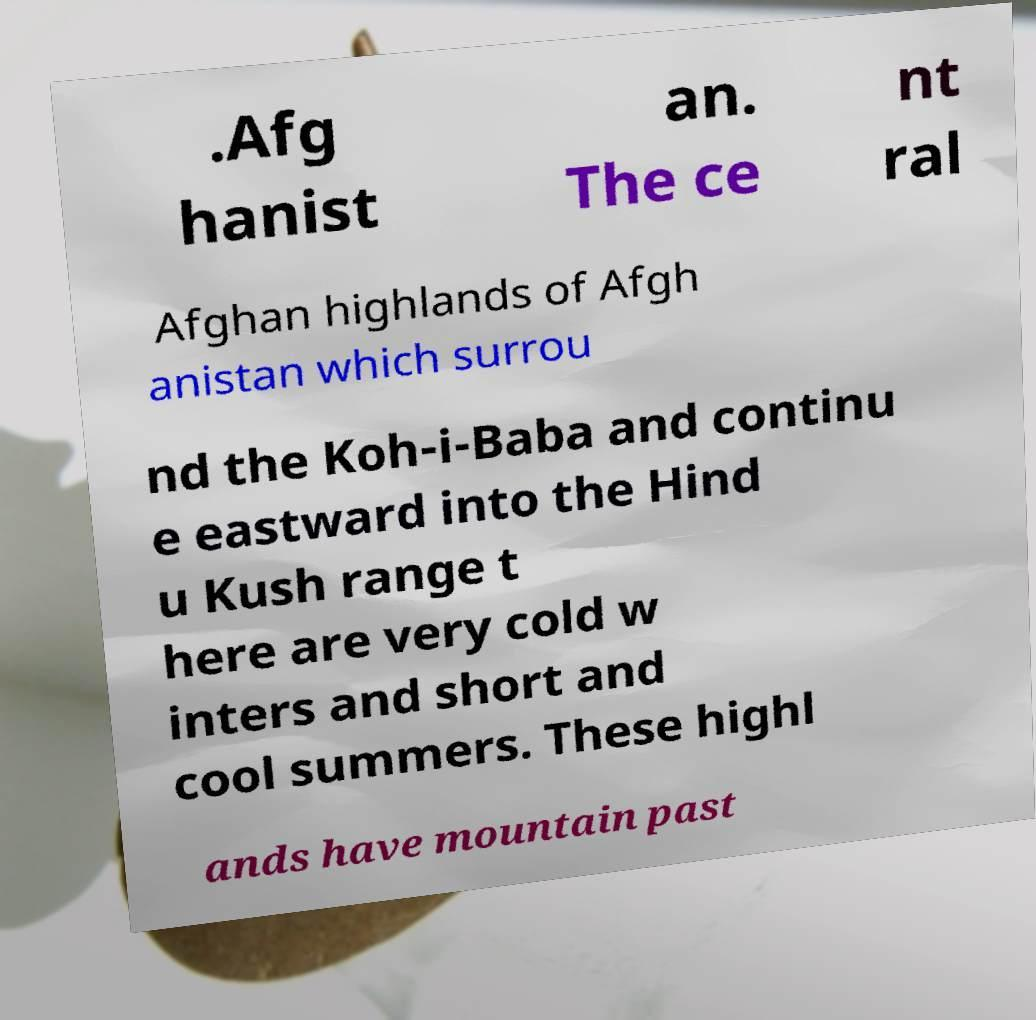Can you read and provide the text displayed in the image?This photo seems to have some interesting text. Can you extract and type it out for me? .Afg hanist an. The ce nt ral Afghan highlands of Afgh anistan which surrou nd the Koh-i-Baba and continu e eastward into the Hind u Kush range t here are very cold w inters and short and cool summers. These highl ands have mountain past 